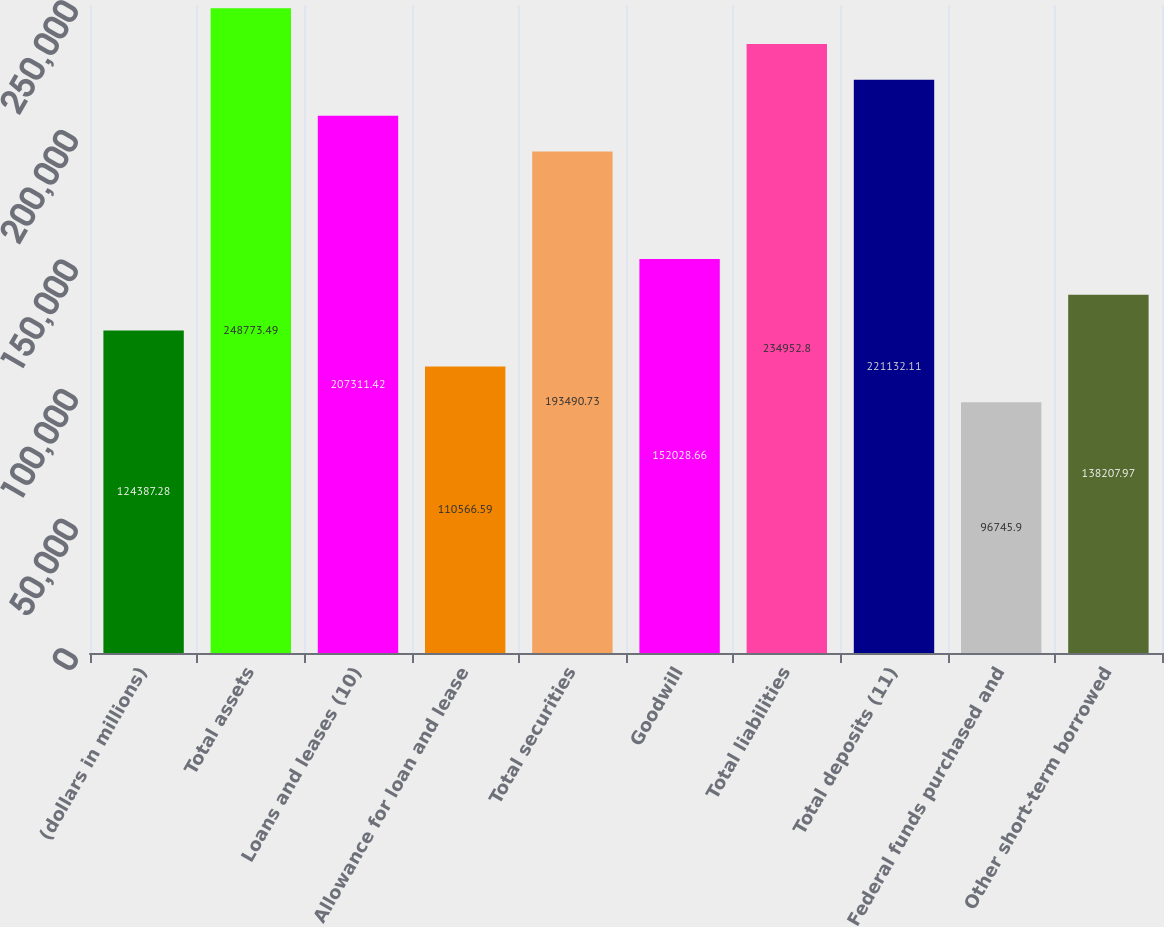Convert chart to OTSL. <chart><loc_0><loc_0><loc_500><loc_500><bar_chart><fcel>(dollars in millions)<fcel>Total assets<fcel>Loans and leases (10)<fcel>Allowance for loan and lease<fcel>Total securities<fcel>Goodwill<fcel>Total liabilities<fcel>Total deposits (11)<fcel>Federal funds purchased and<fcel>Other short-term borrowed<nl><fcel>124387<fcel>248773<fcel>207311<fcel>110567<fcel>193491<fcel>152029<fcel>234953<fcel>221132<fcel>96745.9<fcel>138208<nl></chart> 